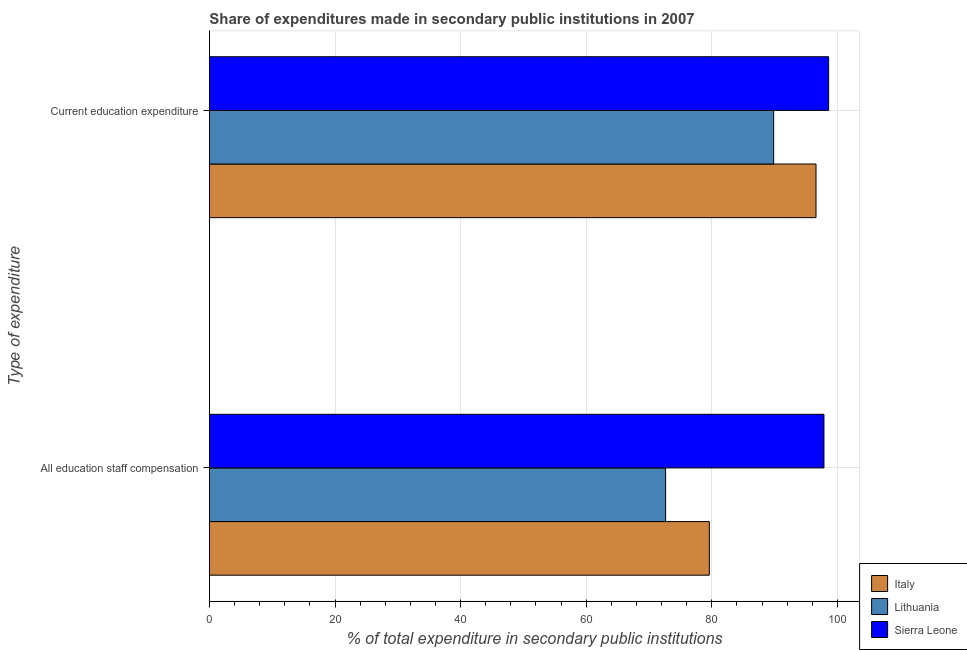How many different coloured bars are there?
Provide a short and direct response. 3. How many groups of bars are there?
Offer a very short reply. 2. Are the number of bars on each tick of the Y-axis equal?
Your answer should be compact. Yes. How many bars are there on the 2nd tick from the top?
Your response must be concise. 3. What is the label of the 2nd group of bars from the top?
Keep it short and to the point. All education staff compensation. What is the expenditure in staff compensation in Italy?
Offer a terse response. 79.6. Across all countries, what is the maximum expenditure in education?
Offer a very short reply. 98.6. Across all countries, what is the minimum expenditure in education?
Provide a short and direct response. 89.84. In which country was the expenditure in staff compensation maximum?
Your answer should be very brief. Sierra Leone. In which country was the expenditure in education minimum?
Offer a very short reply. Lithuania. What is the total expenditure in staff compensation in the graph?
Give a very brief answer. 250.09. What is the difference between the expenditure in education in Italy and that in Sierra Leone?
Make the answer very short. -2.01. What is the difference between the expenditure in staff compensation in Sierra Leone and the expenditure in education in Lithuania?
Offer a very short reply. 8.01. What is the average expenditure in education per country?
Your response must be concise. 95.01. What is the difference between the expenditure in education and expenditure in staff compensation in Italy?
Give a very brief answer. 16.99. What is the ratio of the expenditure in education in Lithuania to that in Sierra Leone?
Ensure brevity in your answer.  0.91. Is the expenditure in education in Lithuania less than that in Italy?
Offer a terse response. Yes. In how many countries, is the expenditure in education greater than the average expenditure in education taken over all countries?
Provide a succinct answer. 2. What does the 2nd bar from the top in All education staff compensation represents?
Your answer should be very brief. Lithuania. Are all the bars in the graph horizontal?
Provide a short and direct response. Yes. How many countries are there in the graph?
Offer a very short reply. 3. Does the graph contain grids?
Your answer should be very brief. Yes. Where does the legend appear in the graph?
Keep it short and to the point. Bottom right. What is the title of the graph?
Ensure brevity in your answer.  Share of expenditures made in secondary public institutions in 2007. Does "Luxembourg" appear as one of the legend labels in the graph?
Offer a very short reply. No. What is the label or title of the X-axis?
Your response must be concise. % of total expenditure in secondary public institutions. What is the label or title of the Y-axis?
Your answer should be compact. Type of expenditure. What is the % of total expenditure in secondary public institutions of Italy in All education staff compensation?
Keep it short and to the point. 79.6. What is the % of total expenditure in secondary public institutions of Lithuania in All education staff compensation?
Your answer should be compact. 72.64. What is the % of total expenditure in secondary public institutions of Sierra Leone in All education staff compensation?
Offer a very short reply. 97.85. What is the % of total expenditure in secondary public institutions in Italy in Current education expenditure?
Offer a terse response. 96.59. What is the % of total expenditure in secondary public institutions of Lithuania in Current education expenditure?
Provide a short and direct response. 89.84. What is the % of total expenditure in secondary public institutions of Sierra Leone in Current education expenditure?
Give a very brief answer. 98.6. Across all Type of expenditure, what is the maximum % of total expenditure in secondary public institutions of Italy?
Your answer should be very brief. 96.59. Across all Type of expenditure, what is the maximum % of total expenditure in secondary public institutions of Lithuania?
Make the answer very short. 89.84. Across all Type of expenditure, what is the maximum % of total expenditure in secondary public institutions of Sierra Leone?
Your response must be concise. 98.6. Across all Type of expenditure, what is the minimum % of total expenditure in secondary public institutions of Italy?
Keep it short and to the point. 79.6. Across all Type of expenditure, what is the minimum % of total expenditure in secondary public institutions in Lithuania?
Your response must be concise. 72.64. Across all Type of expenditure, what is the minimum % of total expenditure in secondary public institutions of Sierra Leone?
Offer a very short reply. 97.85. What is the total % of total expenditure in secondary public institutions in Italy in the graph?
Your response must be concise. 176.19. What is the total % of total expenditure in secondary public institutions in Lithuania in the graph?
Provide a succinct answer. 162.48. What is the total % of total expenditure in secondary public institutions of Sierra Leone in the graph?
Provide a succinct answer. 196.45. What is the difference between the % of total expenditure in secondary public institutions of Italy in All education staff compensation and that in Current education expenditure?
Make the answer very short. -16.99. What is the difference between the % of total expenditure in secondary public institutions of Lithuania in All education staff compensation and that in Current education expenditure?
Keep it short and to the point. -17.2. What is the difference between the % of total expenditure in secondary public institutions in Sierra Leone in All education staff compensation and that in Current education expenditure?
Your answer should be very brief. -0.74. What is the difference between the % of total expenditure in secondary public institutions in Italy in All education staff compensation and the % of total expenditure in secondary public institutions in Lithuania in Current education expenditure?
Your answer should be compact. -10.24. What is the difference between the % of total expenditure in secondary public institutions of Italy in All education staff compensation and the % of total expenditure in secondary public institutions of Sierra Leone in Current education expenditure?
Your answer should be very brief. -19. What is the difference between the % of total expenditure in secondary public institutions of Lithuania in All education staff compensation and the % of total expenditure in secondary public institutions of Sierra Leone in Current education expenditure?
Offer a very short reply. -25.96. What is the average % of total expenditure in secondary public institutions of Italy per Type of expenditure?
Keep it short and to the point. 88.09. What is the average % of total expenditure in secondary public institutions of Lithuania per Type of expenditure?
Ensure brevity in your answer.  81.24. What is the average % of total expenditure in secondary public institutions of Sierra Leone per Type of expenditure?
Offer a terse response. 98.23. What is the difference between the % of total expenditure in secondary public institutions in Italy and % of total expenditure in secondary public institutions in Lithuania in All education staff compensation?
Give a very brief answer. 6.96. What is the difference between the % of total expenditure in secondary public institutions in Italy and % of total expenditure in secondary public institutions in Sierra Leone in All education staff compensation?
Ensure brevity in your answer.  -18.26. What is the difference between the % of total expenditure in secondary public institutions of Lithuania and % of total expenditure in secondary public institutions of Sierra Leone in All education staff compensation?
Provide a succinct answer. -25.21. What is the difference between the % of total expenditure in secondary public institutions of Italy and % of total expenditure in secondary public institutions of Lithuania in Current education expenditure?
Your answer should be compact. 6.75. What is the difference between the % of total expenditure in secondary public institutions of Italy and % of total expenditure in secondary public institutions of Sierra Leone in Current education expenditure?
Offer a very short reply. -2.01. What is the difference between the % of total expenditure in secondary public institutions of Lithuania and % of total expenditure in secondary public institutions of Sierra Leone in Current education expenditure?
Offer a very short reply. -8.76. What is the ratio of the % of total expenditure in secondary public institutions in Italy in All education staff compensation to that in Current education expenditure?
Your response must be concise. 0.82. What is the ratio of the % of total expenditure in secondary public institutions of Lithuania in All education staff compensation to that in Current education expenditure?
Offer a terse response. 0.81. What is the ratio of the % of total expenditure in secondary public institutions in Sierra Leone in All education staff compensation to that in Current education expenditure?
Give a very brief answer. 0.99. What is the difference between the highest and the second highest % of total expenditure in secondary public institutions of Italy?
Your answer should be very brief. 16.99. What is the difference between the highest and the second highest % of total expenditure in secondary public institutions in Lithuania?
Offer a very short reply. 17.2. What is the difference between the highest and the second highest % of total expenditure in secondary public institutions in Sierra Leone?
Make the answer very short. 0.74. What is the difference between the highest and the lowest % of total expenditure in secondary public institutions in Italy?
Keep it short and to the point. 16.99. What is the difference between the highest and the lowest % of total expenditure in secondary public institutions in Lithuania?
Keep it short and to the point. 17.2. What is the difference between the highest and the lowest % of total expenditure in secondary public institutions in Sierra Leone?
Ensure brevity in your answer.  0.74. 